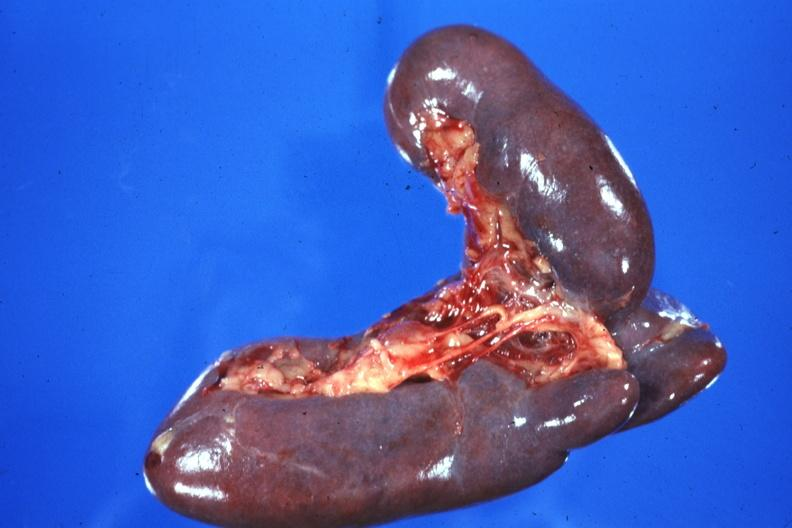what is present?
Answer the question using a single word or phrase. Spleen 